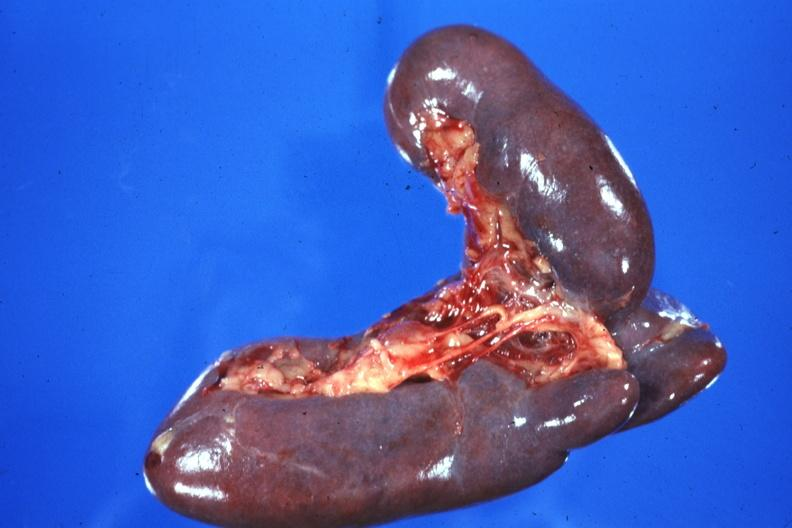what is present?
Answer the question using a single word or phrase. Spleen 